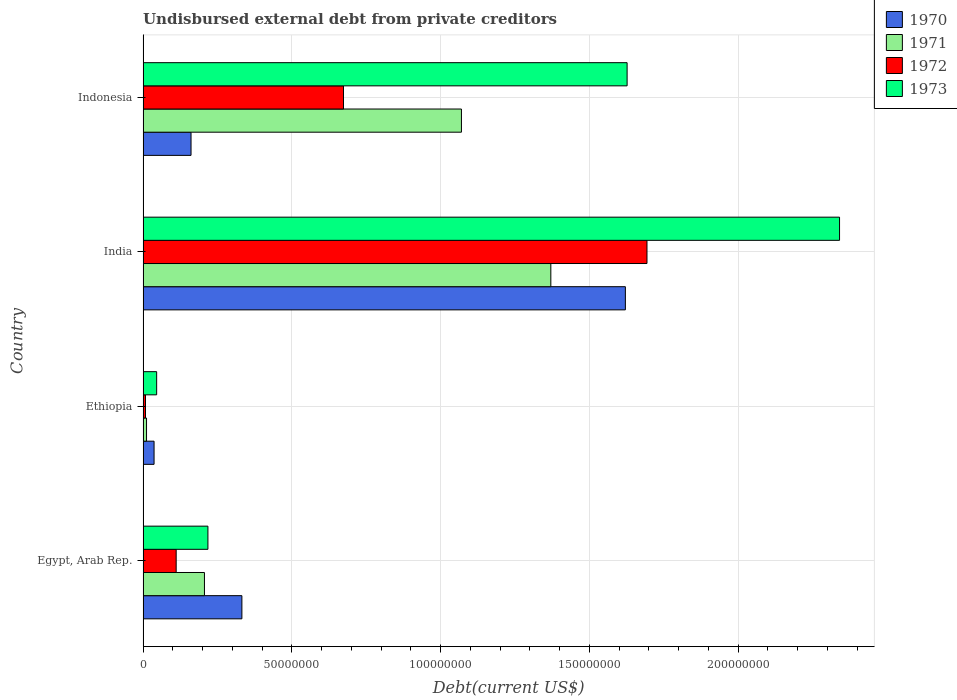How many different coloured bars are there?
Make the answer very short. 4. How many groups of bars are there?
Your answer should be compact. 4. Are the number of bars per tick equal to the number of legend labels?
Provide a succinct answer. Yes. Are the number of bars on each tick of the Y-axis equal?
Your answer should be compact. Yes. How many bars are there on the 3rd tick from the top?
Give a very brief answer. 4. What is the label of the 3rd group of bars from the top?
Your answer should be compact. Ethiopia. In how many cases, is the number of bars for a given country not equal to the number of legend labels?
Offer a very short reply. 0. What is the total debt in 1970 in Egypt, Arab Rep.?
Your answer should be very brief. 3.32e+07. Across all countries, what is the maximum total debt in 1972?
Your answer should be compact. 1.69e+08. Across all countries, what is the minimum total debt in 1971?
Ensure brevity in your answer.  1.16e+06. In which country was the total debt in 1972 minimum?
Offer a terse response. Ethiopia. What is the total total debt in 1971 in the graph?
Offer a terse response. 2.66e+08. What is the difference between the total debt in 1972 in Ethiopia and that in Indonesia?
Your answer should be very brief. -6.66e+07. What is the difference between the total debt in 1970 in Egypt, Arab Rep. and the total debt in 1971 in Indonesia?
Your response must be concise. -7.38e+07. What is the average total debt in 1972 per country?
Ensure brevity in your answer.  6.22e+07. What is the difference between the total debt in 1972 and total debt in 1970 in India?
Keep it short and to the point. 7.26e+06. In how many countries, is the total debt in 1972 greater than 30000000 US$?
Ensure brevity in your answer.  2. What is the ratio of the total debt in 1972 in Egypt, Arab Rep. to that in Ethiopia?
Keep it short and to the point. 13.57. Is the total debt in 1971 in Egypt, Arab Rep. less than that in India?
Provide a short and direct response. Yes. What is the difference between the highest and the second highest total debt in 1973?
Provide a succinct answer. 7.14e+07. What is the difference between the highest and the lowest total debt in 1973?
Make the answer very short. 2.30e+08. In how many countries, is the total debt in 1970 greater than the average total debt in 1970 taken over all countries?
Make the answer very short. 1. Is the sum of the total debt in 1970 in Ethiopia and Indonesia greater than the maximum total debt in 1973 across all countries?
Provide a short and direct response. No. What does the 3rd bar from the top in Egypt, Arab Rep. represents?
Offer a very short reply. 1971. What does the 3rd bar from the bottom in Indonesia represents?
Ensure brevity in your answer.  1972. Are all the bars in the graph horizontal?
Provide a short and direct response. Yes. Does the graph contain any zero values?
Ensure brevity in your answer.  No. How many legend labels are there?
Offer a terse response. 4. What is the title of the graph?
Provide a short and direct response. Undisbursed external debt from private creditors. Does "1965" appear as one of the legend labels in the graph?
Offer a terse response. No. What is the label or title of the X-axis?
Give a very brief answer. Debt(current US$). What is the label or title of the Y-axis?
Make the answer very short. Country. What is the Debt(current US$) of 1970 in Egypt, Arab Rep.?
Make the answer very short. 3.32e+07. What is the Debt(current US$) of 1971 in Egypt, Arab Rep.?
Your answer should be compact. 2.06e+07. What is the Debt(current US$) of 1972 in Egypt, Arab Rep.?
Give a very brief answer. 1.11e+07. What is the Debt(current US$) of 1973 in Egypt, Arab Rep.?
Your answer should be very brief. 2.18e+07. What is the Debt(current US$) in 1970 in Ethiopia?
Keep it short and to the point. 3.70e+06. What is the Debt(current US$) in 1971 in Ethiopia?
Offer a very short reply. 1.16e+06. What is the Debt(current US$) of 1972 in Ethiopia?
Ensure brevity in your answer.  8.20e+05. What is the Debt(current US$) in 1973 in Ethiopia?
Offer a terse response. 4.57e+06. What is the Debt(current US$) of 1970 in India?
Ensure brevity in your answer.  1.62e+08. What is the Debt(current US$) of 1971 in India?
Your answer should be very brief. 1.37e+08. What is the Debt(current US$) in 1972 in India?
Keep it short and to the point. 1.69e+08. What is the Debt(current US$) of 1973 in India?
Offer a very short reply. 2.34e+08. What is the Debt(current US$) of 1970 in Indonesia?
Your answer should be very brief. 1.61e+07. What is the Debt(current US$) in 1971 in Indonesia?
Give a very brief answer. 1.07e+08. What is the Debt(current US$) in 1972 in Indonesia?
Make the answer very short. 6.74e+07. What is the Debt(current US$) of 1973 in Indonesia?
Provide a short and direct response. 1.63e+08. Across all countries, what is the maximum Debt(current US$) of 1970?
Make the answer very short. 1.62e+08. Across all countries, what is the maximum Debt(current US$) of 1971?
Give a very brief answer. 1.37e+08. Across all countries, what is the maximum Debt(current US$) in 1972?
Your answer should be very brief. 1.69e+08. Across all countries, what is the maximum Debt(current US$) in 1973?
Offer a terse response. 2.34e+08. Across all countries, what is the minimum Debt(current US$) of 1970?
Offer a very short reply. 3.70e+06. Across all countries, what is the minimum Debt(current US$) of 1971?
Give a very brief answer. 1.16e+06. Across all countries, what is the minimum Debt(current US$) in 1972?
Your answer should be very brief. 8.20e+05. Across all countries, what is the minimum Debt(current US$) of 1973?
Provide a short and direct response. 4.57e+06. What is the total Debt(current US$) of 1970 in the graph?
Make the answer very short. 2.15e+08. What is the total Debt(current US$) in 1971 in the graph?
Your answer should be compact. 2.66e+08. What is the total Debt(current US$) of 1972 in the graph?
Provide a succinct answer. 2.49e+08. What is the total Debt(current US$) in 1973 in the graph?
Provide a succinct answer. 4.23e+08. What is the difference between the Debt(current US$) of 1970 in Egypt, Arab Rep. and that in Ethiopia?
Offer a terse response. 2.95e+07. What is the difference between the Debt(current US$) in 1971 in Egypt, Arab Rep. and that in Ethiopia?
Make the answer very short. 1.95e+07. What is the difference between the Debt(current US$) in 1972 in Egypt, Arab Rep. and that in Ethiopia?
Make the answer very short. 1.03e+07. What is the difference between the Debt(current US$) of 1973 in Egypt, Arab Rep. and that in Ethiopia?
Your answer should be very brief. 1.72e+07. What is the difference between the Debt(current US$) of 1970 in Egypt, Arab Rep. and that in India?
Keep it short and to the point. -1.29e+08. What is the difference between the Debt(current US$) of 1971 in Egypt, Arab Rep. and that in India?
Provide a succinct answer. -1.16e+08. What is the difference between the Debt(current US$) of 1972 in Egypt, Arab Rep. and that in India?
Provide a short and direct response. -1.58e+08. What is the difference between the Debt(current US$) of 1973 in Egypt, Arab Rep. and that in India?
Ensure brevity in your answer.  -2.12e+08. What is the difference between the Debt(current US$) in 1970 in Egypt, Arab Rep. and that in Indonesia?
Make the answer very short. 1.71e+07. What is the difference between the Debt(current US$) of 1971 in Egypt, Arab Rep. and that in Indonesia?
Provide a succinct answer. -8.64e+07. What is the difference between the Debt(current US$) in 1972 in Egypt, Arab Rep. and that in Indonesia?
Provide a short and direct response. -5.62e+07. What is the difference between the Debt(current US$) in 1973 in Egypt, Arab Rep. and that in Indonesia?
Provide a succinct answer. -1.41e+08. What is the difference between the Debt(current US$) in 1970 in Ethiopia and that in India?
Your answer should be compact. -1.58e+08. What is the difference between the Debt(current US$) in 1971 in Ethiopia and that in India?
Offer a terse response. -1.36e+08. What is the difference between the Debt(current US$) in 1972 in Ethiopia and that in India?
Give a very brief answer. -1.69e+08. What is the difference between the Debt(current US$) in 1973 in Ethiopia and that in India?
Provide a short and direct response. -2.30e+08. What is the difference between the Debt(current US$) of 1970 in Ethiopia and that in Indonesia?
Ensure brevity in your answer.  -1.24e+07. What is the difference between the Debt(current US$) in 1971 in Ethiopia and that in Indonesia?
Give a very brief answer. -1.06e+08. What is the difference between the Debt(current US$) of 1972 in Ethiopia and that in Indonesia?
Provide a short and direct response. -6.66e+07. What is the difference between the Debt(current US$) in 1973 in Ethiopia and that in Indonesia?
Keep it short and to the point. -1.58e+08. What is the difference between the Debt(current US$) in 1970 in India and that in Indonesia?
Make the answer very short. 1.46e+08. What is the difference between the Debt(current US$) of 1971 in India and that in Indonesia?
Ensure brevity in your answer.  3.00e+07. What is the difference between the Debt(current US$) in 1972 in India and that in Indonesia?
Keep it short and to the point. 1.02e+08. What is the difference between the Debt(current US$) in 1973 in India and that in Indonesia?
Provide a short and direct response. 7.14e+07. What is the difference between the Debt(current US$) in 1970 in Egypt, Arab Rep. and the Debt(current US$) in 1971 in Ethiopia?
Your answer should be very brief. 3.21e+07. What is the difference between the Debt(current US$) in 1970 in Egypt, Arab Rep. and the Debt(current US$) in 1972 in Ethiopia?
Ensure brevity in your answer.  3.24e+07. What is the difference between the Debt(current US$) of 1970 in Egypt, Arab Rep. and the Debt(current US$) of 1973 in Ethiopia?
Your answer should be very brief. 2.87e+07. What is the difference between the Debt(current US$) of 1971 in Egypt, Arab Rep. and the Debt(current US$) of 1972 in Ethiopia?
Your response must be concise. 1.98e+07. What is the difference between the Debt(current US$) of 1971 in Egypt, Arab Rep. and the Debt(current US$) of 1973 in Ethiopia?
Provide a short and direct response. 1.61e+07. What is the difference between the Debt(current US$) of 1972 in Egypt, Arab Rep. and the Debt(current US$) of 1973 in Ethiopia?
Your response must be concise. 6.56e+06. What is the difference between the Debt(current US$) of 1970 in Egypt, Arab Rep. and the Debt(current US$) of 1971 in India?
Your answer should be very brief. -1.04e+08. What is the difference between the Debt(current US$) in 1970 in Egypt, Arab Rep. and the Debt(current US$) in 1972 in India?
Your answer should be very brief. -1.36e+08. What is the difference between the Debt(current US$) of 1970 in Egypt, Arab Rep. and the Debt(current US$) of 1973 in India?
Provide a short and direct response. -2.01e+08. What is the difference between the Debt(current US$) of 1971 in Egypt, Arab Rep. and the Debt(current US$) of 1972 in India?
Your response must be concise. -1.49e+08. What is the difference between the Debt(current US$) of 1971 in Egypt, Arab Rep. and the Debt(current US$) of 1973 in India?
Ensure brevity in your answer.  -2.13e+08. What is the difference between the Debt(current US$) in 1972 in Egypt, Arab Rep. and the Debt(current US$) in 1973 in India?
Give a very brief answer. -2.23e+08. What is the difference between the Debt(current US$) of 1970 in Egypt, Arab Rep. and the Debt(current US$) of 1971 in Indonesia?
Make the answer very short. -7.38e+07. What is the difference between the Debt(current US$) of 1970 in Egypt, Arab Rep. and the Debt(current US$) of 1972 in Indonesia?
Your answer should be compact. -3.42e+07. What is the difference between the Debt(current US$) of 1970 in Egypt, Arab Rep. and the Debt(current US$) of 1973 in Indonesia?
Your answer should be very brief. -1.29e+08. What is the difference between the Debt(current US$) in 1971 in Egypt, Arab Rep. and the Debt(current US$) in 1972 in Indonesia?
Offer a very short reply. -4.67e+07. What is the difference between the Debt(current US$) in 1971 in Egypt, Arab Rep. and the Debt(current US$) in 1973 in Indonesia?
Give a very brief answer. -1.42e+08. What is the difference between the Debt(current US$) in 1972 in Egypt, Arab Rep. and the Debt(current US$) in 1973 in Indonesia?
Keep it short and to the point. -1.52e+08. What is the difference between the Debt(current US$) of 1970 in Ethiopia and the Debt(current US$) of 1971 in India?
Your response must be concise. -1.33e+08. What is the difference between the Debt(current US$) of 1970 in Ethiopia and the Debt(current US$) of 1972 in India?
Your answer should be very brief. -1.66e+08. What is the difference between the Debt(current US$) of 1970 in Ethiopia and the Debt(current US$) of 1973 in India?
Ensure brevity in your answer.  -2.30e+08. What is the difference between the Debt(current US$) in 1971 in Ethiopia and the Debt(current US$) in 1972 in India?
Your answer should be compact. -1.68e+08. What is the difference between the Debt(current US$) in 1971 in Ethiopia and the Debt(current US$) in 1973 in India?
Give a very brief answer. -2.33e+08. What is the difference between the Debt(current US$) in 1972 in Ethiopia and the Debt(current US$) in 1973 in India?
Your answer should be very brief. -2.33e+08. What is the difference between the Debt(current US$) in 1970 in Ethiopia and the Debt(current US$) in 1971 in Indonesia?
Offer a terse response. -1.03e+08. What is the difference between the Debt(current US$) of 1970 in Ethiopia and the Debt(current US$) of 1972 in Indonesia?
Provide a succinct answer. -6.37e+07. What is the difference between the Debt(current US$) in 1970 in Ethiopia and the Debt(current US$) in 1973 in Indonesia?
Ensure brevity in your answer.  -1.59e+08. What is the difference between the Debt(current US$) in 1971 in Ethiopia and the Debt(current US$) in 1972 in Indonesia?
Give a very brief answer. -6.62e+07. What is the difference between the Debt(current US$) of 1971 in Ethiopia and the Debt(current US$) of 1973 in Indonesia?
Your response must be concise. -1.62e+08. What is the difference between the Debt(current US$) in 1972 in Ethiopia and the Debt(current US$) in 1973 in Indonesia?
Offer a terse response. -1.62e+08. What is the difference between the Debt(current US$) in 1970 in India and the Debt(current US$) in 1971 in Indonesia?
Offer a very short reply. 5.51e+07. What is the difference between the Debt(current US$) in 1970 in India and the Debt(current US$) in 1972 in Indonesia?
Make the answer very short. 9.47e+07. What is the difference between the Debt(current US$) of 1970 in India and the Debt(current US$) of 1973 in Indonesia?
Keep it short and to the point. -5.84e+05. What is the difference between the Debt(current US$) in 1971 in India and the Debt(current US$) in 1972 in Indonesia?
Your answer should be very brief. 6.97e+07. What is the difference between the Debt(current US$) in 1971 in India and the Debt(current US$) in 1973 in Indonesia?
Offer a terse response. -2.56e+07. What is the difference between the Debt(current US$) of 1972 in India and the Debt(current US$) of 1973 in Indonesia?
Offer a very short reply. 6.68e+06. What is the average Debt(current US$) in 1970 per country?
Offer a very short reply. 5.38e+07. What is the average Debt(current US$) in 1971 per country?
Keep it short and to the point. 6.65e+07. What is the average Debt(current US$) in 1972 per country?
Keep it short and to the point. 6.22e+07. What is the average Debt(current US$) of 1973 per country?
Offer a very short reply. 1.06e+08. What is the difference between the Debt(current US$) of 1970 and Debt(current US$) of 1971 in Egypt, Arab Rep.?
Give a very brief answer. 1.26e+07. What is the difference between the Debt(current US$) of 1970 and Debt(current US$) of 1972 in Egypt, Arab Rep.?
Your response must be concise. 2.21e+07. What is the difference between the Debt(current US$) in 1970 and Debt(current US$) in 1973 in Egypt, Arab Rep.?
Provide a short and direct response. 1.14e+07. What is the difference between the Debt(current US$) in 1971 and Debt(current US$) in 1972 in Egypt, Arab Rep.?
Offer a terse response. 9.50e+06. What is the difference between the Debt(current US$) in 1971 and Debt(current US$) in 1973 in Egypt, Arab Rep.?
Give a very brief answer. -1.17e+06. What is the difference between the Debt(current US$) of 1972 and Debt(current US$) of 1973 in Egypt, Arab Rep.?
Your answer should be compact. -1.07e+07. What is the difference between the Debt(current US$) of 1970 and Debt(current US$) of 1971 in Ethiopia?
Your answer should be compact. 2.53e+06. What is the difference between the Debt(current US$) of 1970 and Debt(current US$) of 1972 in Ethiopia?
Offer a very short reply. 2.88e+06. What is the difference between the Debt(current US$) of 1970 and Debt(current US$) of 1973 in Ethiopia?
Provide a succinct answer. -8.70e+05. What is the difference between the Debt(current US$) of 1971 and Debt(current US$) of 1972 in Ethiopia?
Your answer should be compact. 3.45e+05. What is the difference between the Debt(current US$) of 1971 and Debt(current US$) of 1973 in Ethiopia?
Your response must be concise. -3.40e+06. What is the difference between the Debt(current US$) in 1972 and Debt(current US$) in 1973 in Ethiopia?
Make the answer very short. -3.75e+06. What is the difference between the Debt(current US$) in 1970 and Debt(current US$) in 1971 in India?
Ensure brevity in your answer.  2.51e+07. What is the difference between the Debt(current US$) in 1970 and Debt(current US$) in 1972 in India?
Your response must be concise. -7.26e+06. What is the difference between the Debt(current US$) of 1970 and Debt(current US$) of 1973 in India?
Offer a terse response. -7.20e+07. What is the difference between the Debt(current US$) of 1971 and Debt(current US$) of 1972 in India?
Provide a succinct answer. -3.23e+07. What is the difference between the Debt(current US$) of 1971 and Debt(current US$) of 1973 in India?
Offer a terse response. -9.70e+07. What is the difference between the Debt(current US$) of 1972 and Debt(current US$) of 1973 in India?
Ensure brevity in your answer.  -6.47e+07. What is the difference between the Debt(current US$) of 1970 and Debt(current US$) of 1971 in Indonesia?
Make the answer very short. -9.09e+07. What is the difference between the Debt(current US$) of 1970 and Debt(current US$) of 1972 in Indonesia?
Your answer should be very brief. -5.12e+07. What is the difference between the Debt(current US$) in 1970 and Debt(current US$) in 1973 in Indonesia?
Keep it short and to the point. -1.47e+08. What is the difference between the Debt(current US$) of 1971 and Debt(current US$) of 1972 in Indonesia?
Your answer should be very brief. 3.96e+07. What is the difference between the Debt(current US$) in 1971 and Debt(current US$) in 1973 in Indonesia?
Your answer should be very brief. -5.57e+07. What is the difference between the Debt(current US$) of 1972 and Debt(current US$) of 1973 in Indonesia?
Your answer should be compact. -9.53e+07. What is the ratio of the Debt(current US$) in 1970 in Egypt, Arab Rep. to that in Ethiopia?
Your response must be concise. 8.99. What is the ratio of the Debt(current US$) of 1971 in Egypt, Arab Rep. to that in Ethiopia?
Ensure brevity in your answer.  17.71. What is the ratio of the Debt(current US$) in 1972 in Egypt, Arab Rep. to that in Ethiopia?
Offer a very short reply. 13.57. What is the ratio of the Debt(current US$) in 1973 in Egypt, Arab Rep. to that in Ethiopia?
Your answer should be very brief. 4.77. What is the ratio of the Debt(current US$) of 1970 in Egypt, Arab Rep. to that in India?
Provide a succinct answer. 0.2. What is the ratio of the Debt(current US$) in 1971 in Egypt, Arab Rep. to that in India?
Your answer should be very brief. 0.15. What is the ratio of the Debt(current US$) in 1972 in Egypt, Arab Rep. to that in India?
Ensure brevity in your answer.  0.07. What is the ratio of the Debt(current US$) of 1973 in Egypt, Arab Rep. to that in India?
Provide a short and direct response. 0.09. What is the ratio of the Debt(current US$) of 1970 in Egypt, Arab Rep. to that in Indonesia?
Make the answer very short. 2.06. What is the ratio of the Debt(current US$) in 1971 in Egypt, Arab Rep. to that in Indonesia?
Ensure brevity in your answer.  0.19. What is the ratio of the Debt(current US$) in 1972 in Egypt, Arab Rep. to that in Indonesia?
Your answer should be compact. 0.17. What is the ratio of the Debt(current US$) in 1973 in Egypt, Arab Rep. to that in Indonesia?
Make the answer very short. 0.13. What is the ratio of the Debt(current US$) of 1970 in Ethiopia to that in India?
Make the answer very short. 0.02. What is the ratio of the Debt(current US$) in 1971 in Ethiopia to that in India?
Ensure brevity in your answer.  0.01. What is the ratio of the Debt(current US$) in 1972 in Ethiopia to that in India?
Make the answer very short. 0. What is the ratio of the Debt(current US$) of 1973 in Ethiopia to that in India?
Provide a succinct answer. 0.02. What is the ratio of the Debt(current US$) in 1970 in Ethiopia to that in Indonesia?
Ensure brevity in your answer.  0.23. What is the ratio of the Debt(current US$) in 1971 in Ethiopia to that in Indonesia?
Offer a very short reply. 0.01. What is the ratio of the Debt(current US$) of 1972 in Ethiopia to that in Indonesia?
Provide a short and direct response. 0.01. What is the ratio of the Debt(current US$) of 1973 in Ethiopia to that in Indonesia?
Keep it short and to the point. 0.03. What is the ratio of the Debt(current US$) in 1970 in India to that in Indonesia?
Give a very brief answer. 10.05. What is the ratio of the Debt(current US$) in 1971 in India to that in Indonesia?
Offer a very short reply. 1.28. What is the ratio of the Debt(current US$) in 1972 in India to that in Indonesia?
Ensure brevity in your answer.  2.51. What is the ratio of the Debt(current US$) of 1973 in India to that in Indonesia?
Provide a succinct answer. 1.44. What is the difference between the highest and the second highest Debt(current US$) in 1970?
Provide a succinct answer. 1.29e+08. What is the difference between the highest and the second highest Debt(current US$) in 1971?
Provide a succinct answer. 3.00e+07. What is the difference between the highest and the second highest Debt(current US$) of 1972?
Provide a succinct answer. 1.02e+08. What is the difference between the highest and the second highest Debt(current US$) of 1973?
Offer a very short reply. 7.14e+07. What is the difference between the highest and the lowest Debt(current US$) in 1970?
Keep it short and to the point. 1.58e+08. What is the difference between the highest and the lowest Debt(current US$) of 1971?
Provide a succinct answer. 1.36e+08. What is the difference between the highest and the lowest Debt(current US$) of 1972?
Ensure brevity in your answer.  1.69e+08. What is the difference between the highest and the lowest Debt(current US$) in 1973?
Give a very brief answer. 2.30e+08. 